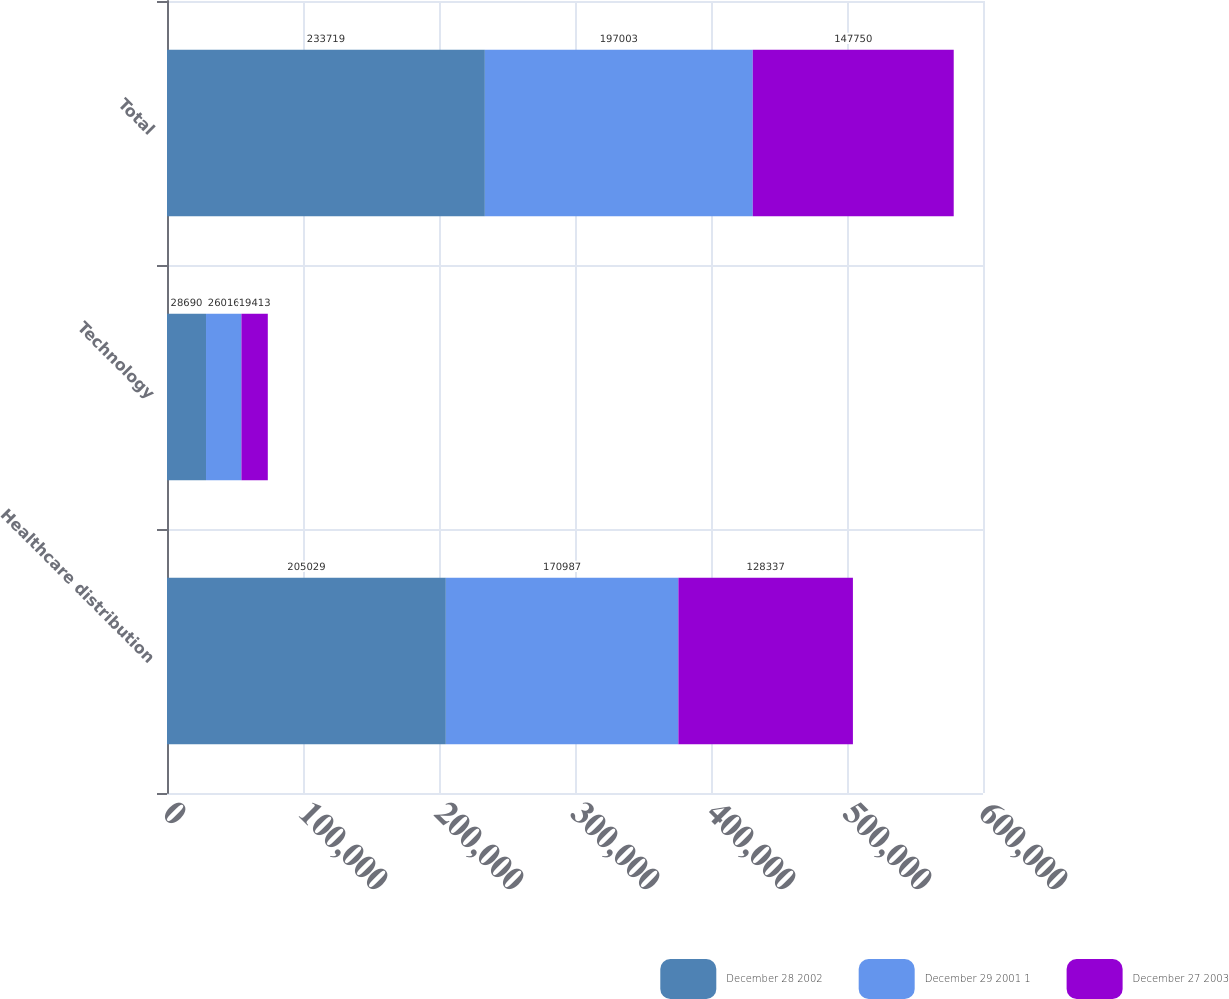Convert chart. <chart><loc_0><loc_0><loc_500><loc_500><stacked_bar_chart><ecel><fcel>Healthcare distribution<fcel>Technology<fcel>Total<nl><fcel>December 28 2002<fcel>205029<fcel>28690<fcel>233719<nl><fcel>December 29 2001 1<fcel>170987<fcel>26016<fcel>197003<nl><fcel>December 27 2003<fcel>128337<fcel>19413<fcel>147750<nl></chart> 